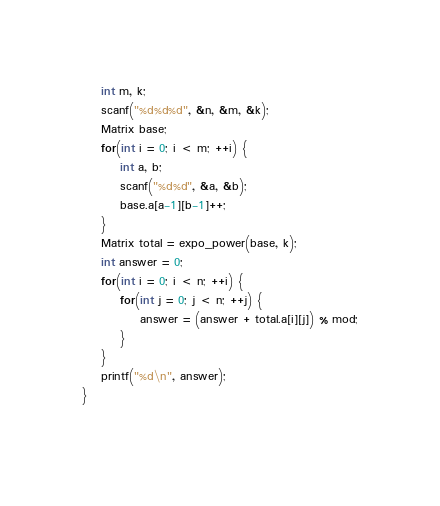Convert code to text. <code><loc_0><loc_0><loc_500><loc_500><_C++_>	int m, k;
	scanf("%d%d%d", &n, &m, &k);
	Matrix base;
	for(int i = 0; i < m; ++i) {
		int a, b;
		scanf("%d%d", &a, &b);
		base.a[a-1][b-1]++;
	}
	Matrix total = expo_power(base, k);
	int answer = 0;
	for(int i = 0; i < n; ++i) {
		for(int j = 0; j < n; ++j) {
			answer = (answer + total.a[i][j]) % mod;
		}
	}
	printf("%d\n", answer);
}
	
</code> 